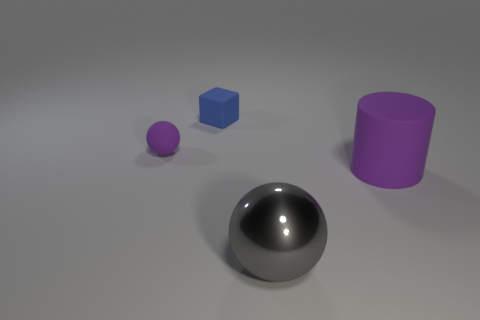Does the big rubber cylinder have the same color as the tiny rubber ball?
Your answer should be compact. Yes. How many other things are there of the same color as the cylinder?
Your answer should be very brief. 1. What shape is the purple thing that is behind the object to the right of the gray ball?
Your answer should be very brief. Sphere. What number of big gray metallic objects are behind the tiny ball?
Your answer should be compact. 0. Is there a small red thing that has the same material as the small purple thing?
Give a very brief answer. No. What is the material of the purple object that is the same size as the blue object?
Provide a short and direct response. Rubber. How big is the object that is both right of the tiny ball and left of the metallic thing?
Your answer should be compact. Small. The matte object that is in front of the small cube and to the right of the purple matte sphere is what color?
Your answer should be very brief. Purple. Is the number of tiny purple matte things in front of the big gray metallic thing less than the number of tiny blue cubes behind the purple rubber cylinder?
Offer a very short reply. Yes. What number of big red things are the same shape as the gray thing?
Ensure brevity in your answer.  0. 